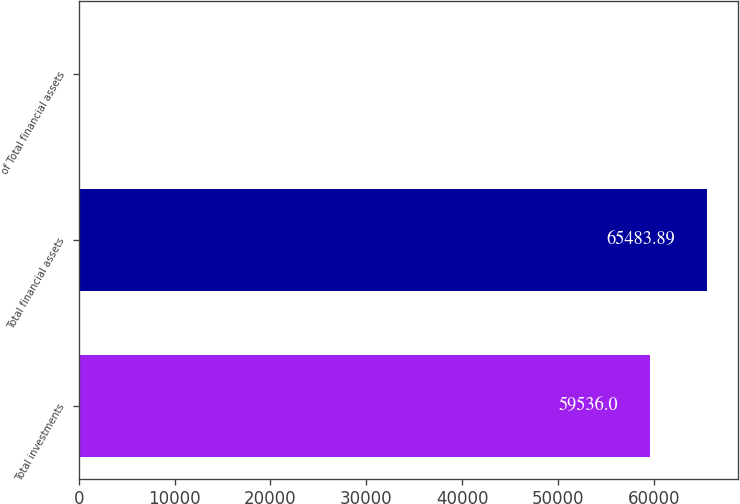<chart> <loc_0><loc_0><loc_500><loc_500><bar_chart><fcel>Total investments<fcel>Total financial assets<fcel>of Total financial assets<nl><fcel>59536<fcel>65483.9<fcel>57.1<nl></chart> 